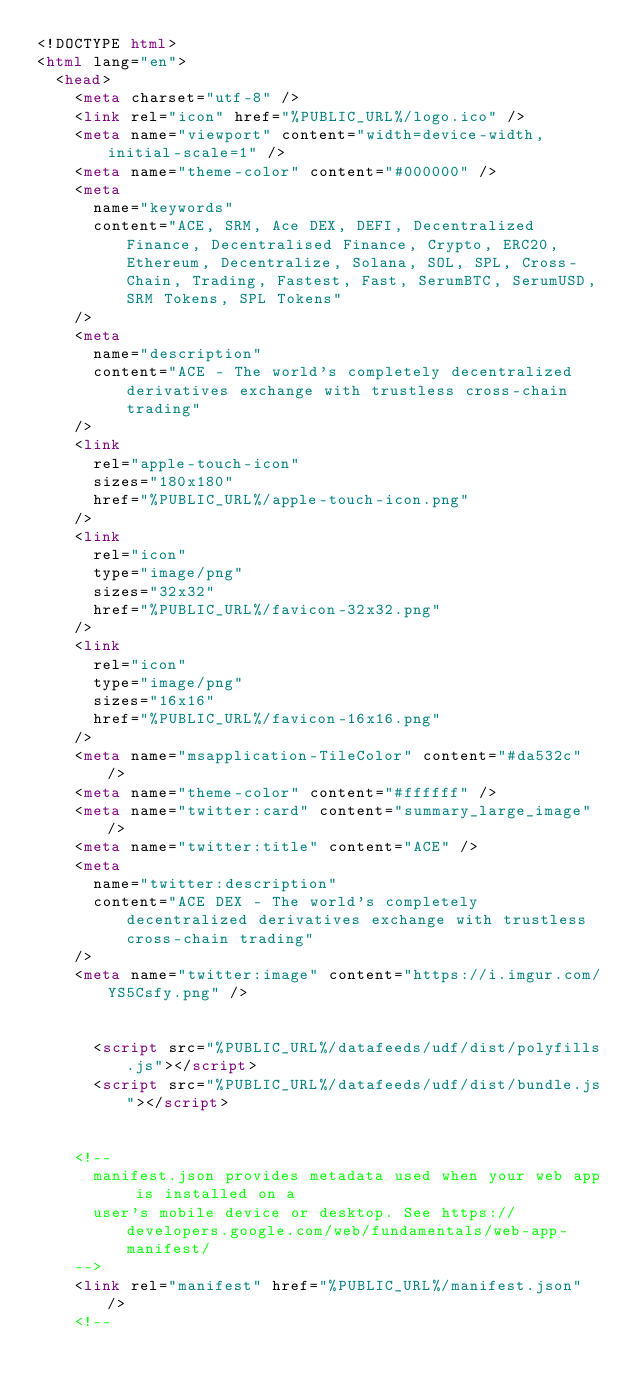Convert code to text. <code><loc_0><loc_0><loc_500><loc_500><_HTML_><!DOCTYPE html>
<html lang="en">
  <head>
    <meta charset="utf-8" />
    <link rel="icon" href="%PUBLIC_URL%/logo.ico" />
    <meta name="viewport" content="width=device-width, initial-scale=1" />
    <meta name="theme-color" content="#000000" />
    <meta
      name="keywords"
      content="ACE, SRM, Ace DEX, DEFI, Decentralized Finance, Decentralised Finance, Crypto, ERC20, Ethereum, Decentralize, Solana, SOL, SPL, Cross-Chain, Trading, Fastest, Fast, SerumBTC, SerumUSD, SRM Tokens, SPL Tokens"
    />
    <meta
      name="description"
      content="ACE - The world's completely decentralized derivatives exchange with trustless cross-chain trading"
    />
    <link
      rel="apple-touch-icon"
      sizes="180x180"
      href="%PUBLIC_URL%/apple-touch-icon.png"
    />
    <link
      rel="icon"
      type="image/png"
      sizes="32x32"
      href="%PUBLIC_URL%/favicon-32x32.png"
    />
    <link
      rel="icon"
      type="image/png"
      sizes="16x16"
      href="%PUBLIC_URL%/favicon-16x16.png"
    />
    <meta name="msapplication-TileColor" content="#da532c" />
    <meta name="theme-color" content="#ffffff" />
    <meta name="twitter:card" content="summary_large_image" />
    <meta name="twitter:title" content="ACE" />
    <meta
      name="twitter:description"
      content="ACE DEX - The world's completely decentralized derivatives exchange with trustless cross-chain trading"
    />
    <meta name="twitter:image" content="https://i.imgur.com/YS5Csfy.png" />
    

      <script src="%PUBLIC_URL%/datafeeds/udf/dist/polyfills.js"></script>
      <script src="%PUBLIC_URL%/datafeeds/udf/dist/bundle.js"></script>
   

    <!--
      manifest.json provides metadata used when your web app is installed on a
      user's mobile device or desktop. See https://developers.google.com/web/fundamentals/web-app-manifest/
    -->
    <link rel="manifest" href="%PUBLIC_URL%/manifest.json" />
    <!--</code> 